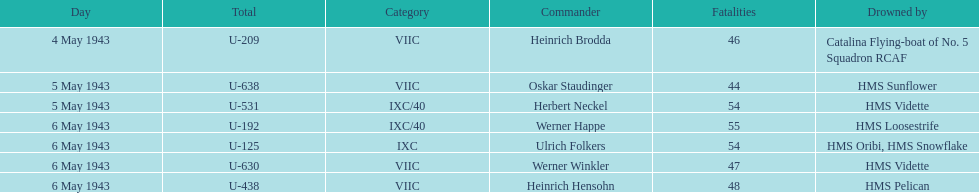Which date had at least 55 casualties? 6 May 1943. Parse the table in full. {'header': ['Day', 'Total', 'Category', 'Commander', 'Fatalities', 'Drowned by'], 'rows': [['4 May 1943', 'U-209', 'VIIC', 'Heinrich Brodda', '46', 'Catalina Flying-boat of No. 5 Squadron RCAF'], ['5 May 1943', 'U-638', 'VIIC', 'Oskar Staudinger', '44', 'HMS Sunflower'], ['5 May 1943', 'U-531', 'IXC/40', 'Herbert Neckel', '54', 'HMS Vidette'], ['6 May 1943', 'U-192', 'IXC/40', 'Werner Happe', '55', 'HMS Loosestrife'], ['6 May 1943', 'U-125', 'IXC', 'Ulrich Folkers', '54', 'HMS Oribi, HMS Snowflake'], ['6 May 1943', 'U-630', 'VIIC', 'Werner Winkler', '47', 'HMS Vidette'], ['6 May 1943', 'U-438', 'VIIC', 'Heinrich Hensohn', '48', 'HMS Pelican']]} 